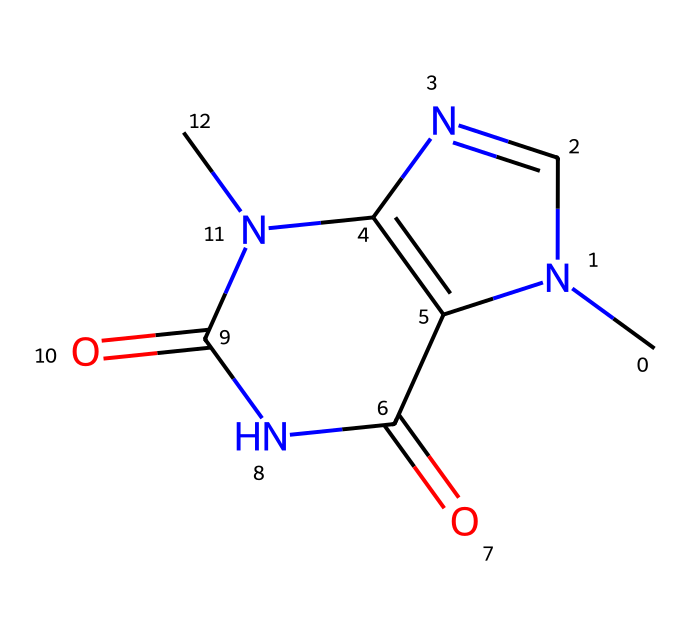What is the main toxic component in chocolate for dogs? The chemical represented is theobromine, which is toxic to canines.
Answer: theobromine How many nitrogen atoms are in this molecule? By examining the structure, there are four nitrogen atoms represented in the SMILES notation.
Answer: four What type of bonding is primarily present in theobromine? The chemical has both covalent and hydrogen bonding due to the presence of multiple atoms and functional groups.
Answer: covalent What physical state is theobromine usually found in? Theobromine is typically found in a solid crystalline form, especially when isolated from chocolate.
Answer: solid Why is theobromine harmful to dogs? Theobromine affects dogs' metabolism significantly slower than humans, leading to toxicity, especially in high doses.
Answer: metabolism How does the structure of theobromine contribute to its toxicity? The presence of nitrogen atoms and the specific arrangement help it to interfere with central nervous system function in dogs.
Answer: central nervous system What is the most common source of theobromine? Chocolate is the most common source, particularly dark chocolate with high cocoa content.
Answer: chocolate 